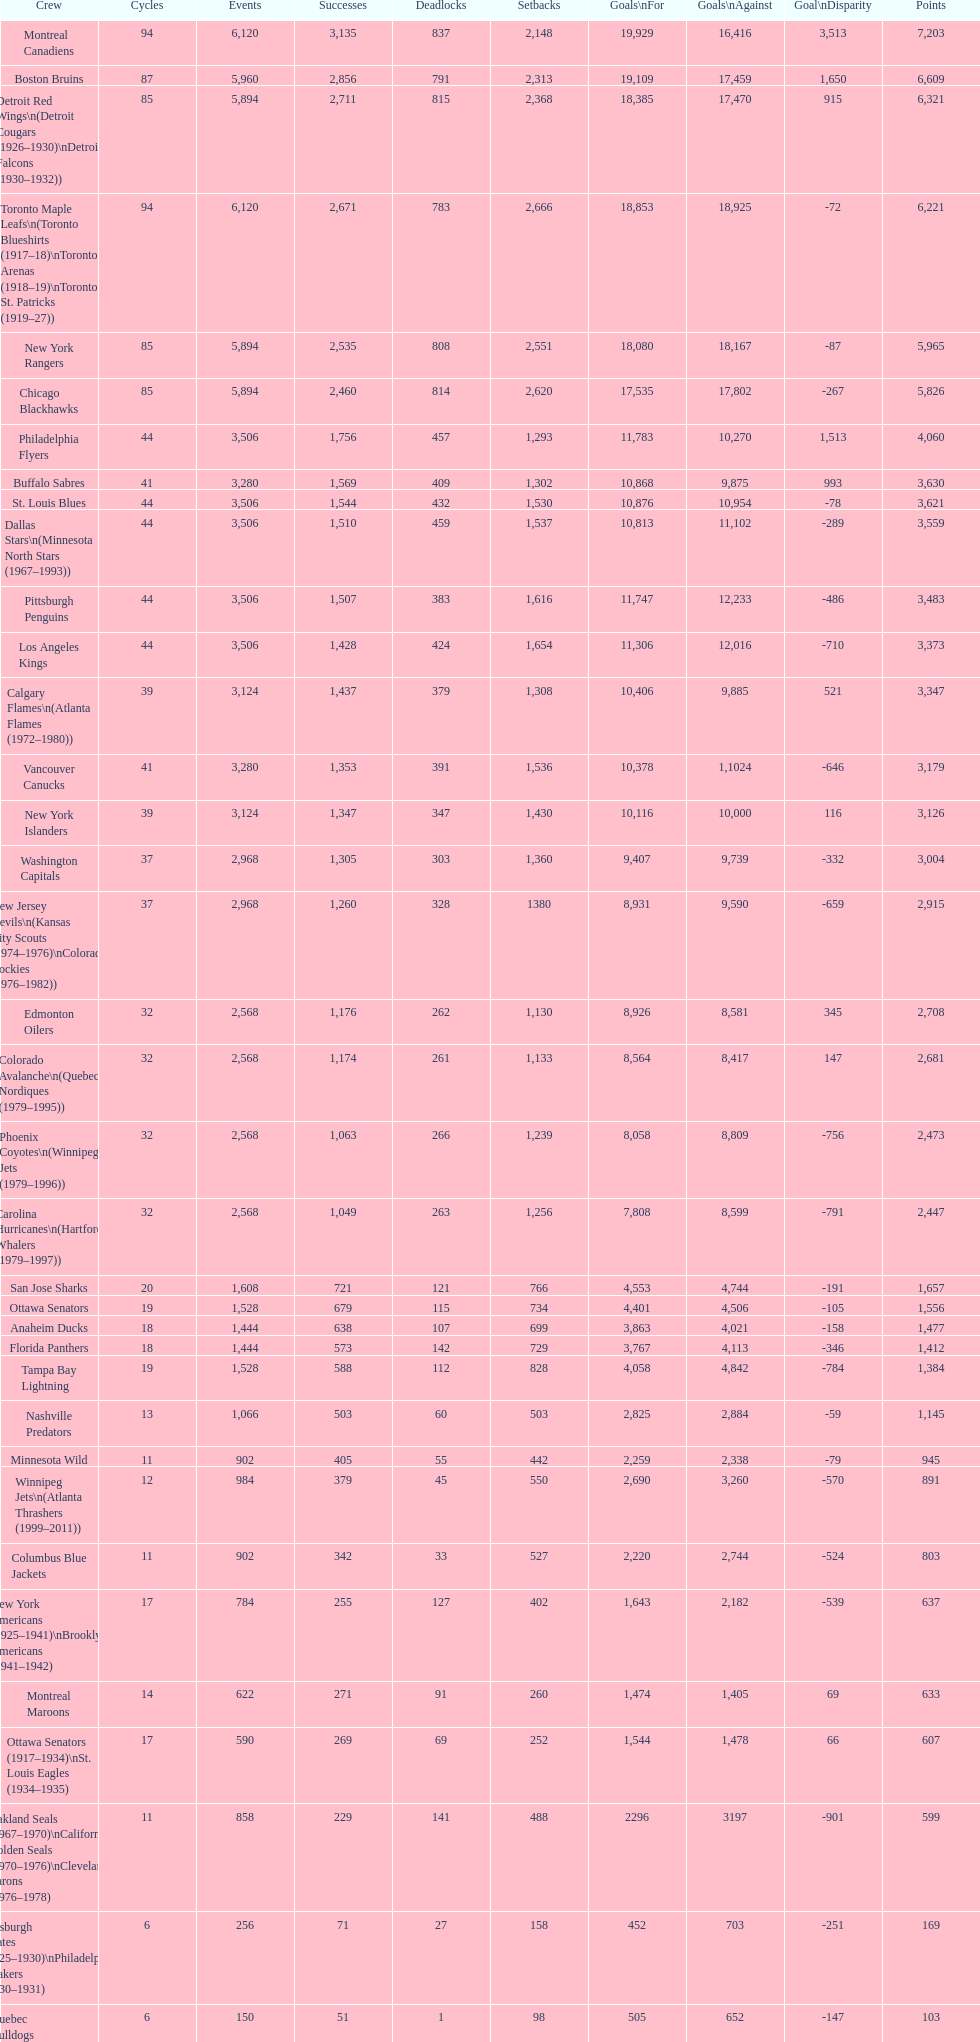Give me the full table as a dictionary. {'header': ['Crew', 'Cycles', 'Events', 'Successes', 'Deadlocks', 'Setbacks', 'Goals\\nFor', 'Goals\\nAgainst', 'Goal\\nDisparity', 'Points'], 'rows': [['Montreal Canadiens', '94', '6,120', '3,135', '837', '2,148', '19,929', '16,416', '3,513', '7,203'], ['Boston Bruins', '87', '5,960', '2,856', '791', '2,313', '19,109', '17,459', '1,650', '6,609'], ['Detroit Red Wings\\n(Detroit Cougars (1926–1930)\\nDetroit Falcons (1930–1932))', '85', '5,894', '2,711', '815', '2,368', '18,385', '17,470', '915', '6,321'], ['Toronto Maple Leafs\\n(Toronto Blueshirts (1917–18)\\nToronto Arenas (1918–19)\\nToronto St. Patricks (1919–27))', '94', '6,120', '2,671', '783', '2,666', '18,853', '18,925', '-72', '6,221'], ['New York Rangers', '85', '5,894', '2,535', '808', '2,551', '18,080', '18,167', '-87', '5,965'], ['Chicago Blackhawks', '85', '5,894', '2,460', '814', '2,620', '17,535', '17,802', '-267', '5,826'], ['Philadelphia Flyers', '44', '3,506', '1,756', '457', '1,293', '11,783', '10,270', '1,513', '4,060'], ['Buffalo Sabres', '41', '3,280', '1,569', '409', '1,302', '10,868', '9,875', '993', '3,630'], ['St. Louis Blues', '44', '3,506', '1,544', '432', '1,530', '10,876', '10,954', '-78', '3,621'], ['Dallas Stars\\n(Minnesota North Stars (1967–1993))', '44', '3,506', '1,510', '459', '1,537', '10,813', '11,102', '-289', '3,559'], ['Pittsburgh Penguins', '44', '3,506', '1,507', '383', '1,616', '11,747', '12,233', '-486', '3,483'], ['Los Angeles Kings', '44', '3,506', '1,428', '424', '1,654', '11,306', '12,016', '-710', '3,373'], ['Calgary Flames\\n(Atlanta Flames (1972–1980))', '39', '3,124', '1,437', '379', '1,308', '10,406', '9,885', '521', '3,347'], ['Vancouver Canucks', '41', '3,280', '1,353', '391', '1,536', '10,378', '1,1024', '-646', '3,179'], ['New York Islanders', '39', '3,124', '1,347', '347', '1,430', '10,116', '10,000', '116', '3,126'], ['Washington Capitals', '37', '2,968', '1,305', '303', '1,360', '9,407', '9,739', '-332', '3,004'], ['New Jersey Devils\\n(Kansas City Scouts (1974–1976)\\nColorado Rockies (1976–1982))', '37', '2,968', '1,260', '328', '1380', '8,931', '9,590', '-659', '2,915'], ['Edmonton Oilers', '32', '2,568', '1,176', '262', '1,130', '8,926', '8,581', '345', '2,708'], ['Colorado Avalanche\\n(Quebec Nordiques (1979–1995))', '32', '2,568', '1,174', '261', '1,133', '8,564', '8,417', '147', '2,681'], ['Phoenix Coyotes\\n(Winnipeg Jets (1979–1996))', '32', '2,568', '1,063', '266', '1,239', '8,058', '8,809', '-756', '2,473'], ['Carolina Hurricanes\\n(Hartford Whalers (1979–1997))', '32', '2,568', '1,049', '263', '1,256', '7,808', '8,599', '-791', '2,447'], ['San Jose Sharks', '20', '1,608', '721', '121', '766', '4,553', '4,744', '-191', '1,657'], ['Ottawa Senators', '19', '1,528', '679', '115', '734', '4,401', '4,506', '-105', '1,556'], ['Anaheim Ducks', '18', '1,444', '638', '107', '699', '3,863', '4,021', '-158', '1,477'], ['Florida Panthers', '18', '1,444', '573', '142', '729', '3,767', '4,113', '-346', '1,412'], ['Tampa Bay Lightning', '19', '1,528', '588', '112', '828', '4,058', '4,842', '-784', '1,384'], ['Nashville Predators', '13', '1,066', '503', '60', '503', '2,825', '2,884', '-59', '1,145'], ['Minnesota Wild', '11', '902', '405', '55', '442', '2,259', '2,338', '-79', '945'], ['Winnipeg Jets\\n(Atlanta Thrashers (1999–2011))', '12', '984', '379', '45', '550', '2,690', '3,260', '-570', '891'], ['Columbus Blue Jackets', '11', '902', '342', '33', '527', '2,220', '2,744', '-524', '803'], ['New York Americans (1925–1941)\\nBrooklyn Americans (1941–1942)', '17', '784', '255', '127', '402', '1,643', '2,182', '-539', '637'], ['Montreal Maroons', '14', '622', '271', '91', '260', '1,474', '1,405', '69', '633'], ['Ottawa Senators (1917–1934)\\nSt. Louis Eagles (1934–1935)', '17', '590', '269', '69', '252', '1,544', '1,478', '66', '607'], ['Oakland Seals (1967–1970)\\nCalifornia Golden Seals (1970–1976)\\nCleveland Barons (1976–1978)', '11', '858', '229', '141', '488', '2296', '3197', '-901', '599'], ['Pittsburgh Pirates (1925–1930)\\nPhiladelphia Quakers (1930–1931)', '6', '256', '71', '27', '158', '452', '703', '-251', '169'], ['Quebec Bulldogs (1919–1920)\\nHamilton Tigers (1920–1925)', '6', '150', '51', '1', '98', '505', '652', '-147', '103'], ['Montreal Wanderers', '1', '6', '1', '0', '5', '17', '35', '-18', '2']]} Which team played the same amount of seasons as the canadiens? Toronto Maple Leafs. 